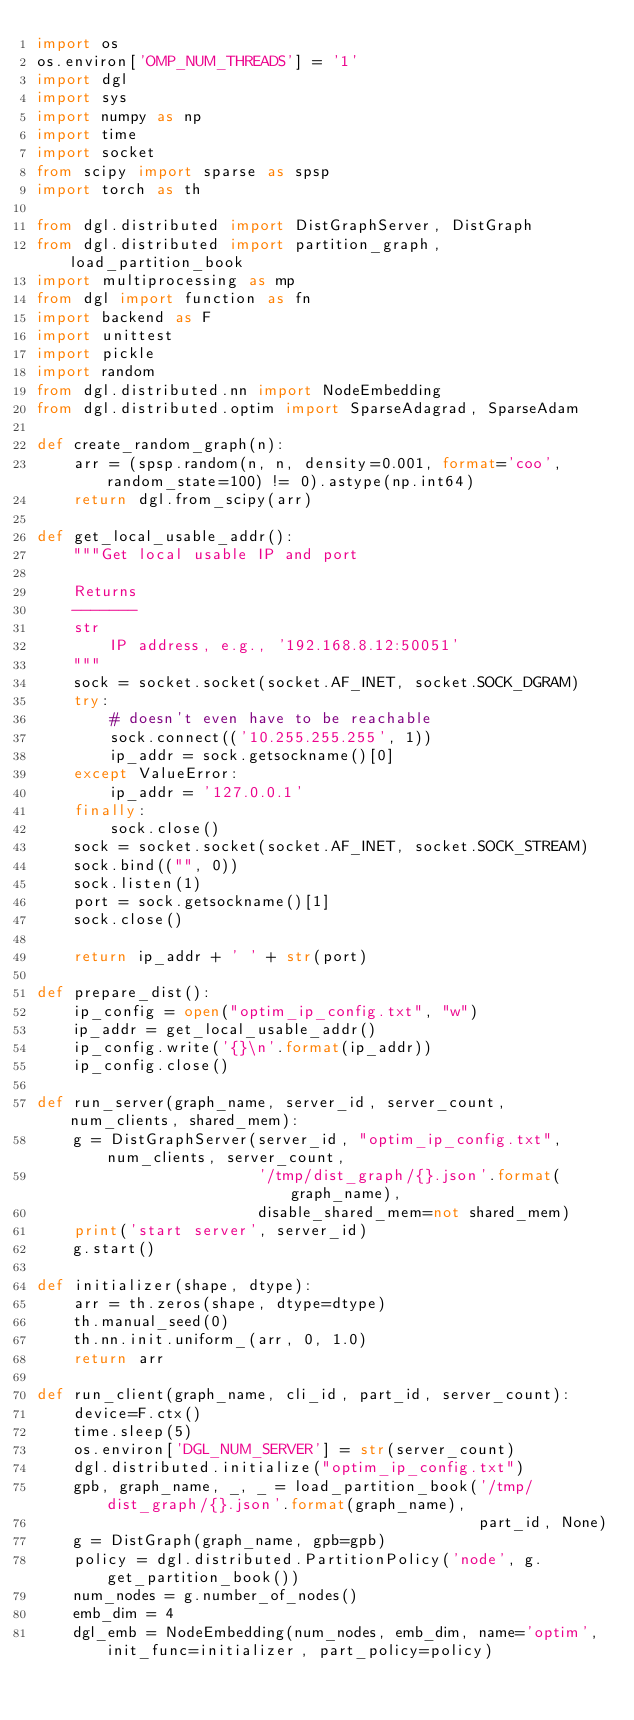<code> <loc_0><loc_0><loc_500><loc_500><_Python_>import os
os.environ['OMP_NUM_THREADS'] = '1'
import dgl
import sys
import numpy as np
import time
import socket
from scipy import sparse as spsp
import torch as th

from dgl.distributed import DistGraphServer, DistGraph
from dgl.distributed import partition_graph, load_partition_book
import multiprocessing as mp
from dgl import function as fn
import backend as F
import unittest
import pickle
import random
from dgl.distributed.nn import NodeEmbedding
from dgl.distributed.optim import SparseAdagrad, SparseAdam

def create_random_graph(n):
    arr = (spsp.random(n, n, density=0.001, format='coo', random_state=100) != 0).astype(np.int64)
    return dgl.from_scipy(arr)

def get_local_usable_addr():
    """Get local usable IP and port

    Returns
    -------
    str
        IP address, e.g., '192.168.8.12:50051'
    """
    sock = socket.socket(socket.AF_INET, socket.SOCK_DGRAM)
    try:
        # doesn't even have to be reachable
        sock.connect(('10.255.255.255', 1))
        ip_addr = sock.getsockname()[0]
    except ValueError:
        ip_addr = '127.0.0.1'
    finally:
        sock.close()
    sock = socket.socket(socket.AF_INET, socket.SOCK_STREAM)
    sock.bind(("", 0))
    sock.listen(1)
    port = sock.getsockname()[1]
    sock.close()

    return ip_addr + ' ' + str(port)

def prepare_dist():
    ip_config = open("optim_ip_config.txt", "w")
    ip_addr = get_local_usable_addr()
    ip_config.write('{}\n'.format(ip_addr))
    ip_config.close()

def run_server(graph_name, server_id, server_count, num_clients, shared_mem):
    g = DistGraphServer(server_id, "optim_ip_config.txt", num_clients, server_count,
                        '/tmp/dist_graph/{}.json'.format(graph_name),
                        disable_shared_mem=not shared_mem)
    print('start server', server_id)
    g.start()

def initializer(shape, dtype):
    arr = th.zeros(shape, dtype=dtype)
    th.manual_seed(0)
    th.nn.init.uniform_(arr, 0, 1.0)
    return arr

def run_client(graph_name, cli_id, part_id, server_count):
    device=F.ctx()
    time.sleep(5)
    os.environ['DGL_NUM_SERVER'] = str(server_count)
    dgl.distributed.initialize("optim_ip_config.txt")
    gpb, graph_name, _, _ = load_partition_book('/tmp/dist_graph/{}.json'.format(graph_name),
                                                part_id, None)
    g = DistGraph(graph_name, gpb=gpb)
    policy = dgl.distributed.PartitionPolicy('node', g.get_partition_book())
    num_nodes = g.number_of_nodes()
    emb_dim = 4
    dgl_emb = NodeEmbedding(num_nodes, emb_dim, name='optim', init_func=initializer, part_policy=policy)</code> 